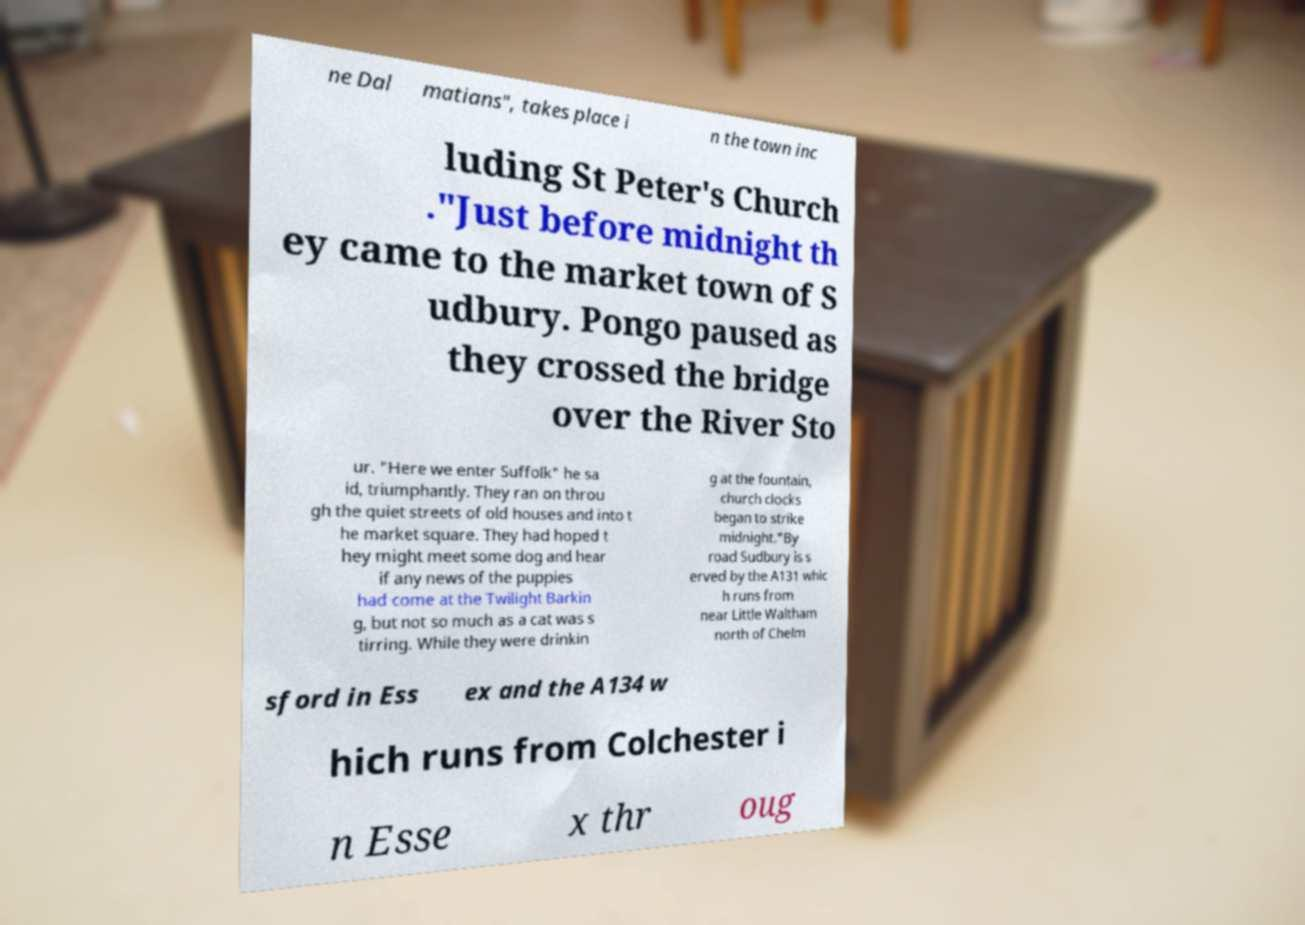Could you assist in decoding the text presented in this image and type it out clearly? ne Dal matians", takes place i n the town inc luding St Peter's Church ."Just before midnight th ey came to the market town of S udbury. Pongo paused as they crossed the bridge over the River Sto ur. "Here we enter Suffolk" he sa id, triumphantly. They ran on throu gh the quiet streets of old houses and into t he market square. They had hoped t hey might meet some dog and hear if any news of the puppies had come at the Twilight Barkin g, but not so much as a cat was s tirring. While they were drinkin g at the fountain, church clocks began to strike midnight."By road Sudbury is s erved by the A131 whic h runs from near Little Waltham north of Chelm sford in Ess ex and the A134 w hich runs from Colchester i n Esse x thr oug 